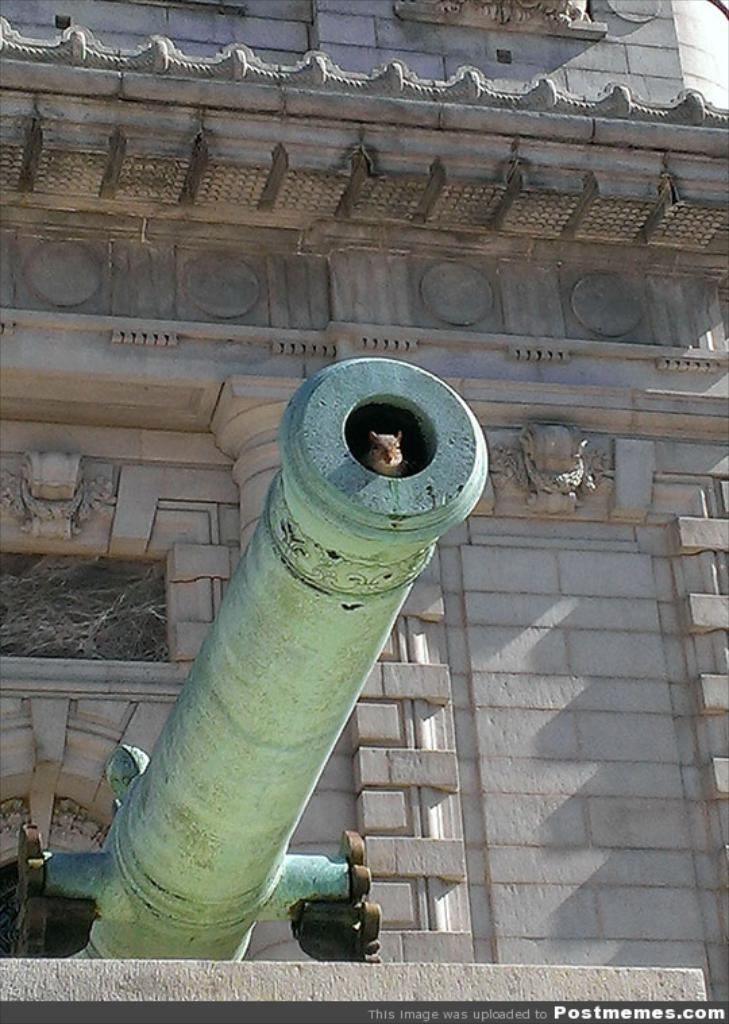What is the main object in the image? There is a cannon in the image. Where is the cannon located in relation to other structures? The cannon is near a building. What small animal can be seen in the image? There is a rat in a hole in the image. What type of building can be seen in the background of the image? There is a historical building in the background of the image. What decorative elements are present on the wall in the background of the image? There are sculptures on the wall in the background of the image. How many cents are visible on the cannon in the image? There are no cents visible on the cannon in the image. What type of room is the cannon located in? The image does not provide information about the room, as it only shows the cannon and its surroundings. 